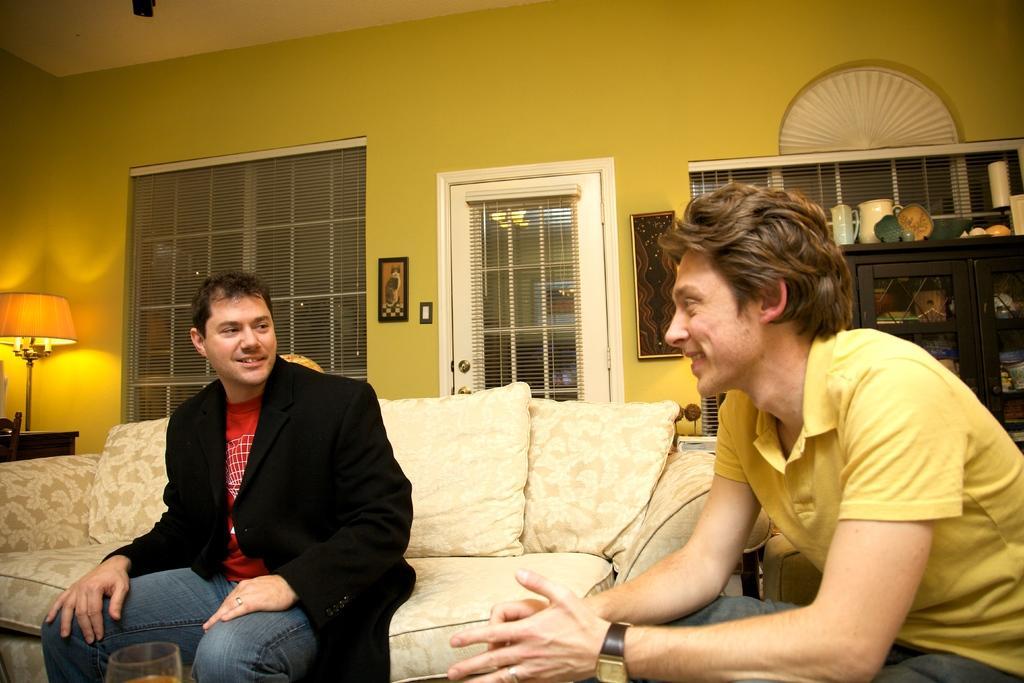Please provide a concise description of this image. In this image, there are two persons sitting on a couch and a chair. On the left side of the image, I can see a table and a lamp. In the background, I can see the windows, a door with blinds and there are photo frames attached to the wall. On the right side of the image, I can see few objects in a cupboard and there are few objects on top of a cupboard. 